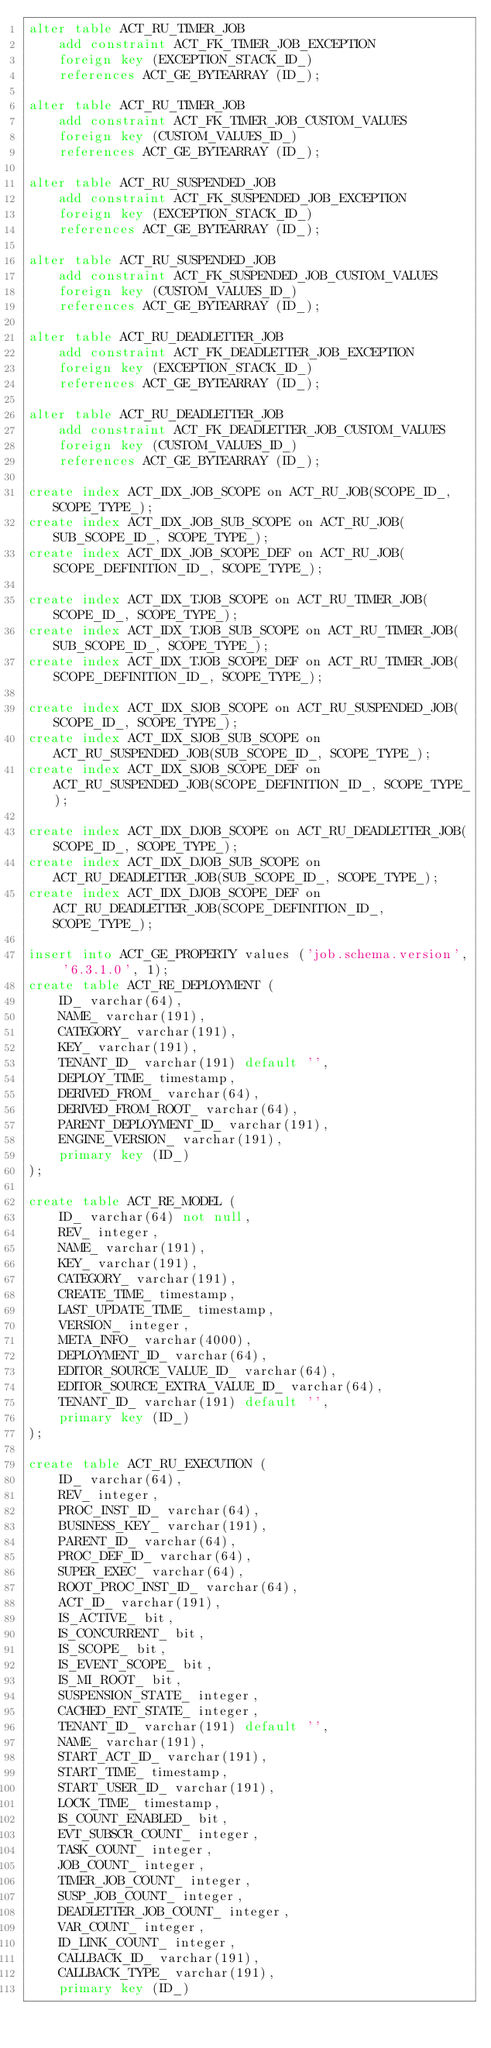<code> <loc_0><loc_0><loc_500><loc_500><_SQL_>alter table ACT_RU_TIMER_JOB
    add constraint ACT_FK_TIMER_JOB_EXCEPTION
    foreign key (EXCEPTION_STACK_ID_)
    references ACT_GE_BYTEARRAY (ID_);

alter table ACT_RU_TIMER_JOB
    add constraint ACT_FK_TIMER_JOB_CUSTOM_VALUES
    foreign key (CUSTOM_VALUES_ID_)
    references ACT_GE_BYTEARRAY (ID_);

alter table ACT_RU_SUSPENDED_JOB
    add constraint ACT_FK_SUSPENDED_JOB_EXCEPTION
    foreign key (EXCEPTION_STACK_ID_)
    references ACT_GE_BYTEARRAY (ID_);

alter table ACT_RU_SUSPENDED_JOB
    add constraint ACT_FK_SUSPENDED_JOB_CUSTOM_VALUES
    foreign key (CUSTOM_VALUES_ID_)
    references ACT_GE_BYTEARRAY (ID_);

alter table ACT_RU_DEADLETTER_JOB
    add constraint ACT_FK_DEADLETTER_JOB_EXCEPTION
    foreign key (EXCEPTION_STACK_ID_)
    references ACT_GE_BYTEARRAY (ID_);

alter table ACT_RU_DEADLETTER_JOB
    add constraint ACT_FK_DEADLETTER_JOB_CUSTOM_VALUES
    foreign key (CUSTOM_VALUES_ID_)
    references ACT_GE_BYTEARRAY (ID_);

create index ACT_IDX_JOB_SCOPE on ACT_RU_JOB(SCOPE_ID_, SCOPE_TYPE_);
create index ACT_IDX_JOB_SUB_SCOPE on ACT_RU_JOB(SUB_SCOPE_ID_, SCOPE_TYPE_);
create index ACT_IDX_JOB_SCOPE_DEF on ACT_RU_JOB(SCOPE_DEFINITION_ID_, SCOPE_TYPE_);

create index ACT_IDX_TJOB_SCOPE on ACT_RU_TIMER_JOB(SCOPE_ID_, SCOPE_TYPE_);
create index ACT_IDX_TJOB_SUB_SCOPE on ACT_RU_TIMER_JOB(SUB_SCOPE_ID_, SCOPE_TYPE_);
create index ACT_IDX_TJOB_SCOPE_DEF on ACT_RU_TIMER_JOB(SCOPE_DEFINITION_ID_, SCOPE_TYPE_); 

create index ACT_IDX_SJOB_SCOPE on ACT_RU_SUSPENDED_JOB(SCOPE_ID_, SCOPE_TYPE_);
create index ACT_IDX_SJOB_SUB_SCOPE on ACT_RU_SUSPENDED_JOB(SUB_SCOPE_ID_, SCOPE_TYPE_);
create index ACT_IDX_SJOB_SCOPE_DEF on ACT_RU_SUSPENDED_JOB(SCOPE_DEFINITION_ID_, SCOPE_TYPE_);   

create index ACT_IDX_DJOB_SCOPE on ACT_RU_DEADLETTER_JOB(SCOPE_ID_, SCOPE_TYPE_);
create index ACT_IDX_DJOB_SUB_SCOPE on ACT_RU_DEADLETTER_JOB(SUB_SCOPE_ID_, SCOPE_TYPE_);
create index ACT_IDX_DJOB_SCOPE_DEF on ACT_RU_DEADLETTER_JOB(SCOPE_DEFINITION_ID_, SCOPE_TYPE_);

insert into ACT_GE_PROPERTY values ('job.schema.version', '6.3.1.0', 1);
create table ACT_RE_DEPLOYMENT (
    ID_ varchar(64),
    NAME_ varchar(191),
    CATEGORY_ varchar(191),
    KEY_ varchar(191),
    TENANT_ID_ varchar(191) default '',
    DEPLOY_TIME_ timestamp,
    DERIVED_FROM_ varchar(64),
    DERIVED_FROM_ROOT_ varchar(64),
    PARENT_DEPLOYMENT_ID_ varchar(191),
    ENGINE_VERSION_ varchar(191),
    primary key (ID_)
);

create table ACT_RE_MODEL (
    ID_ varchar(64) not null,
    REV_ integer,
    NAME_ varchar(191),
    KEY_ varchar(191),
    CATEGORY_ varchar(191),
    CREATE_TIME_ timestamp,
    LAST_UPDATE_TIME_ timestamp,
    VERSION_ integer,
    META_INFO_ varchar(4000),
    DEPLOYMENT_ID_ varchar(64),
    EDITOR_SOURCE_VALUE_ID_ varchar(64),
    EDITOR_SOURCE_EXTRA_VALUE_ID_ varchar(64),
    TENANT_ID_ varchar(191) default '',
    primary key (ID_)
);

create table ACT_RU_EXECUTION (
    ID_ varchar(64),
    REV_ integer,
    PROC_INST_ID_ varchar(64),
    BUSINESS_KEY_ varchar(191),
    PARENT_ID_ varchar(64),
    PROC_DEF_ID_ varchar(64),
    SUPER_EXEC_ varchar(64),
    ROOT_PROC_INST_ID_ varchar(64),
    ACT_ID_ varchar(191),
    IS_ACTIVE_ bit,
    IS_CONCURRENT_ bit,
    IS_SCOPE_ bit,
    IS_EVENT_SCOPE_ bit,
    IS_MI_ROOT_ bit,
    SUSPENSION_STATE_ integer,
    CACHED_ENT_STATE_ integer,
    TENANT_ID_ varchar(191) default '',
    NAME_ varchar(191),
    START_ACT_ID_ varchar(191),
    START_TIME_ timestamp,
    START_USER_ID_ varchar(191),
    LOCK_TIME_ timestamp,
    IS_COUNT_ENABLED_ bit,
    EVT_SUBSCR_COUNT_ integer, 
    TASK_COUNT_ integer, 
    JOB_COUNT_ integer, 
    TIMER_JOB_COUNT_ integer,
    SUSP_JOB_COUNT_ integer,
    DEADLETTER_JOB_COUNT_ integer,
    VAR_COUNT_ integer, 
    ID_LINK_COUNT_ integer,
    CALLBACK_ID_ varchar(191),
    CALLBACK_TYPE_ varchar(191),
    primary key (ID_)</code> 